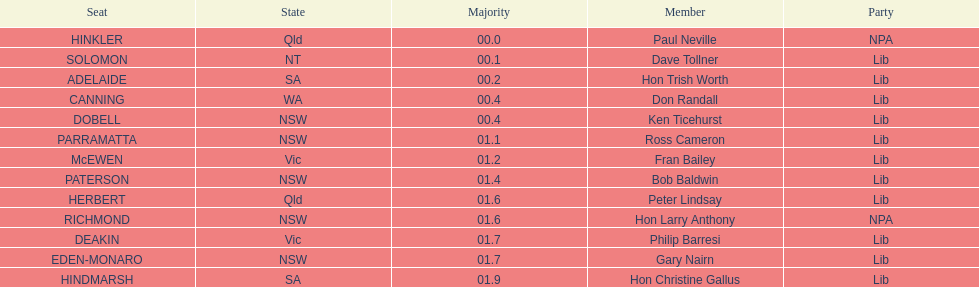How many states were represented in the seats? 6. 